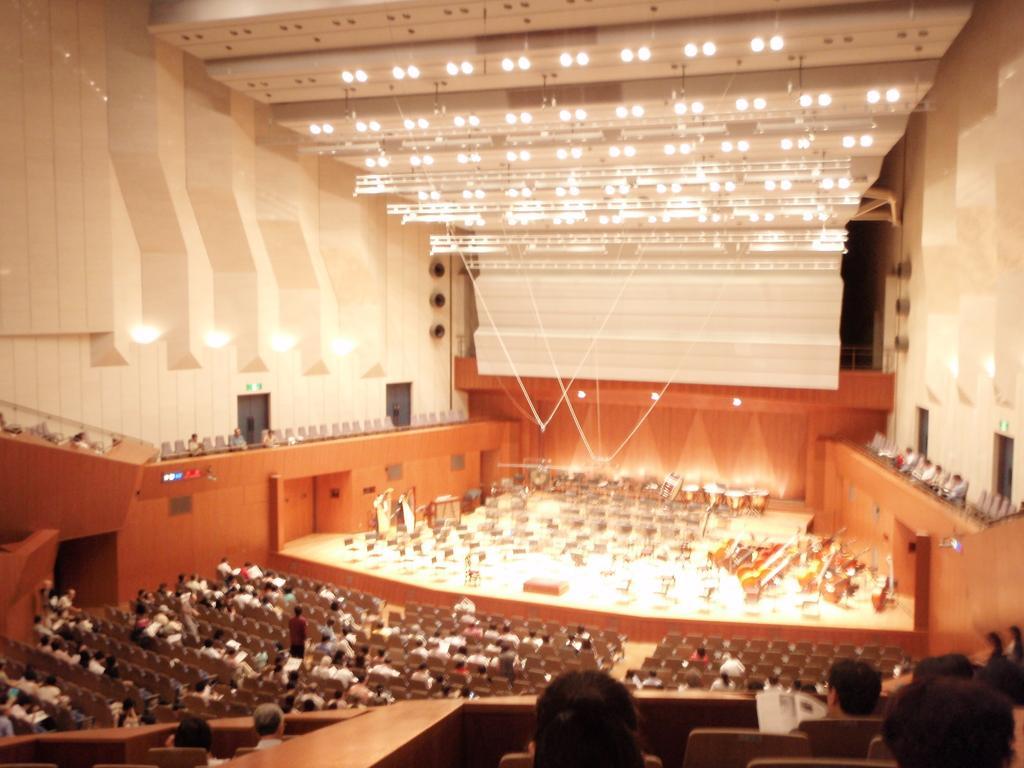Please provide a concise description of this image. In this image, we can see an auditorium. There are some persons and seats at the bottom of the image. There are some musical instruments on the stage. There are lights at the top of the image. 